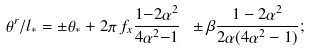Convert formula to latex. <formula><loc_0><loc_0><loc_500><loc_500>\theta ^ { r } / l _ { * } = \pm \theta _ { * } + 2 \pi \, f _ { x } \frac { 1 { - } 2 \alpha ^ { 2 } } { 4 \alpha ^ { 2 } { - } 1 } \ \pm \beta \frac { 1 - 2 \alpha ^ { 2 } } { 2 \alpha ( 4 \alpha ^ { 2 } - 1 ) } ;</formula> 